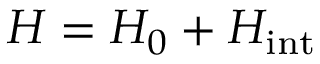Convert formula to latex. <formula><loc_0><loc_0><loc_500><loc_500>H = H _ { 0 } + H _ { i n t }</formula> 